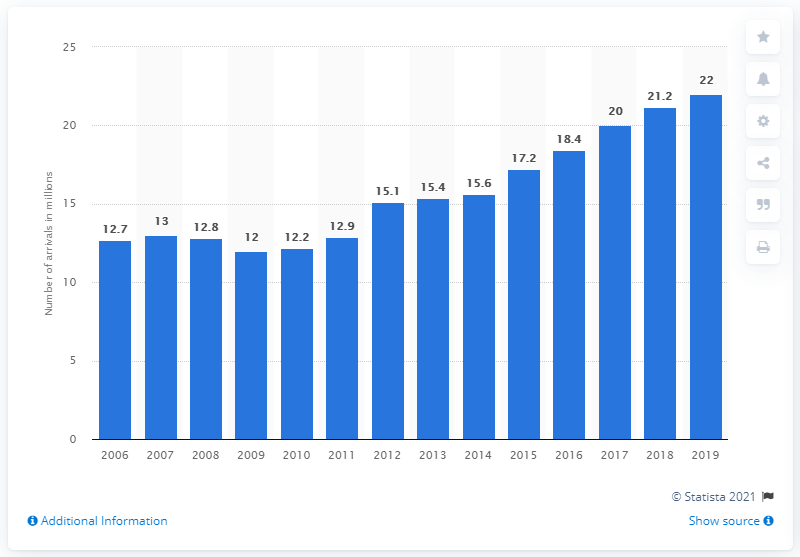Point out several critical features in this image. In 2019, a total of 22 million tourists arrived in the Czech Republic. 